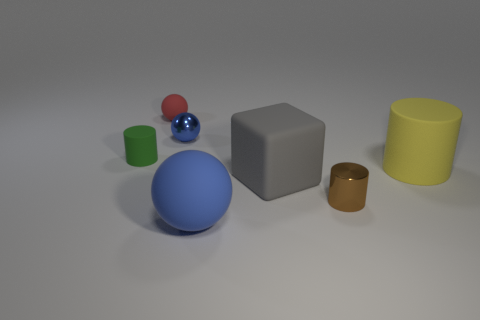Add 1 small objects. How many objects exist? 8 Subtract all balls. How many objects are left? 4 Add 3 tiny brown metal cylinders. How many tiny brown metal cylinders are left? 4 Add 5 small shiny objects. How many small shiny objects exist? 7 Subtract 0 purple cubes. How many objects are left? 7 Subtract all red rubber objects. Subtract all large yellow rubber cylinders. How many objects are left? 5 